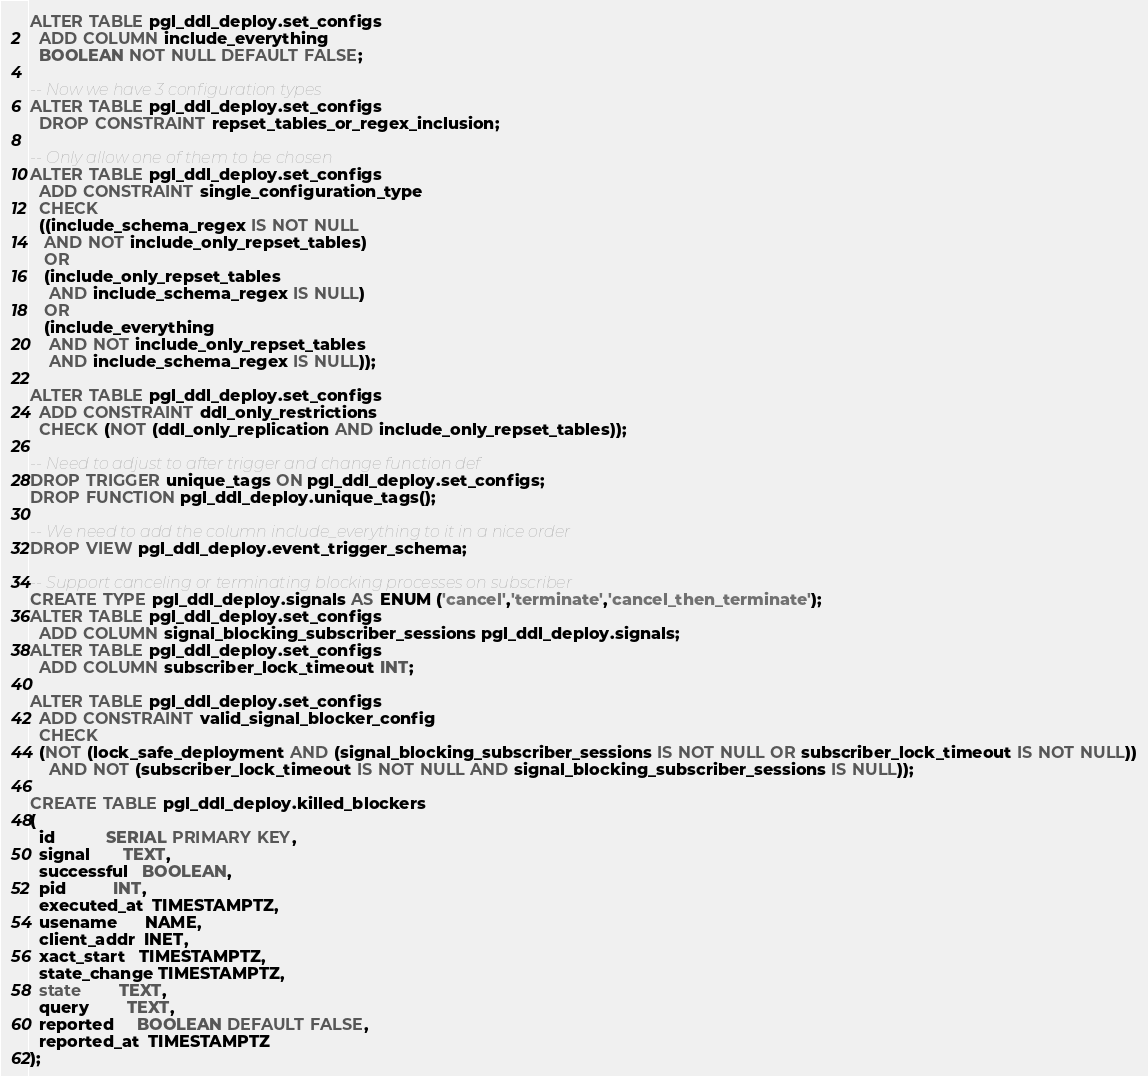Convert code to text. <code><loc_0><loc_0><loc_500><loc_500><_SQL_>ALTER TABLE pgl_ddl_deploy.set_configs
  ADD COLUMN include_everything
  BOOLEAN NOT NULL DEFAULT FALSE;

-- Now we have 3 configuration types
ALTER TABLE pgl_ddl_deploy.set_configs
  DROP CONSTRAINT repset_tables_or_regex_inclusion;

-- Only allow one of them to be chosen
ALTER TABLE pgl_ddl_deploy.set_configs
  ADD CONSTRAINT single_configuration_type
  CHECK
  ((include_schema_regex IS NOT NULL
   AND NOT include_only_repset_tables)
   OR
   (include_only_repset_tables
    AND include_schema_regex IS NULL)
   OR
   (include_everything
    AND NOT include_only_repset_tables
    AND include_schema_regex IS NULL));

ALTER TABLE pgl_ddl_deploy.set_configs
  ADD CONSTRAINT ddl_only_restrictions
  CHECK (NOT (ddl_only_replication AND include_only_repset_tables)); 

-- Need to adjust to after trigger and change function def 
DROP TRIGGER unique_tags ON pgl_ddl_deploy.set_configs;
DROP FUNCTION pgl_ddl_deploy.unique_tags();

-- We need to add the column include_everything to it in a nice order
DROP VIEW pgl_ddl_deploy.event_trigger_schema;

-- Support canceling or terminating blocking processes on subscriber
CREATE TYPE pgl_ddl_deploy.signals AS ENUM ('cancel','terminate','cancel_then_terminate');
ALTER TABLE pgl_ddl_deploy.set_configs
  ADD COLUMN signal_blocking_subscriber_sessions pgl_ddl_deploy.signals;
ALTER TABLE pgl_ddl_deploy.set_configs
  ADD COLUMN subscriber_lock_timeout INT;

ALTER TABLE pgl_ddl_deploy.set_configs
  ADD CONSTRAINT valid_signal_blocker_config
  CHECK
  (NOT (lock_safe_deployment AND (signal_blocking_subscriber_sessions IS NOT NULL OR subscriber_lock_timeout IS NOT NULL))
    AND NOT (subscriber_lock_timeout IS NOT NULL AND signal_blocking_subscriber_sessions IS NULL));

CREATE TABLE pgl_ddl_deploy.killed_blockers
(
  id           SERIAL PRIMARY KEY,
  signal       TEXT,
  successful   BOOLEAN,
  pid          INT,
  executed_at  TIMESTAMPTZ,
  usename      NAME,
  client_addr  INET,
  xact_start   TIMESTAMPTZ,
  state_change TIMESTAMPTZ,
  state        TEXT,
  query        TEXT,
  reported     BOOLEAN DEFAULT FALSE,
  reported_at  TIMESTAMPTZ
);
</code> 